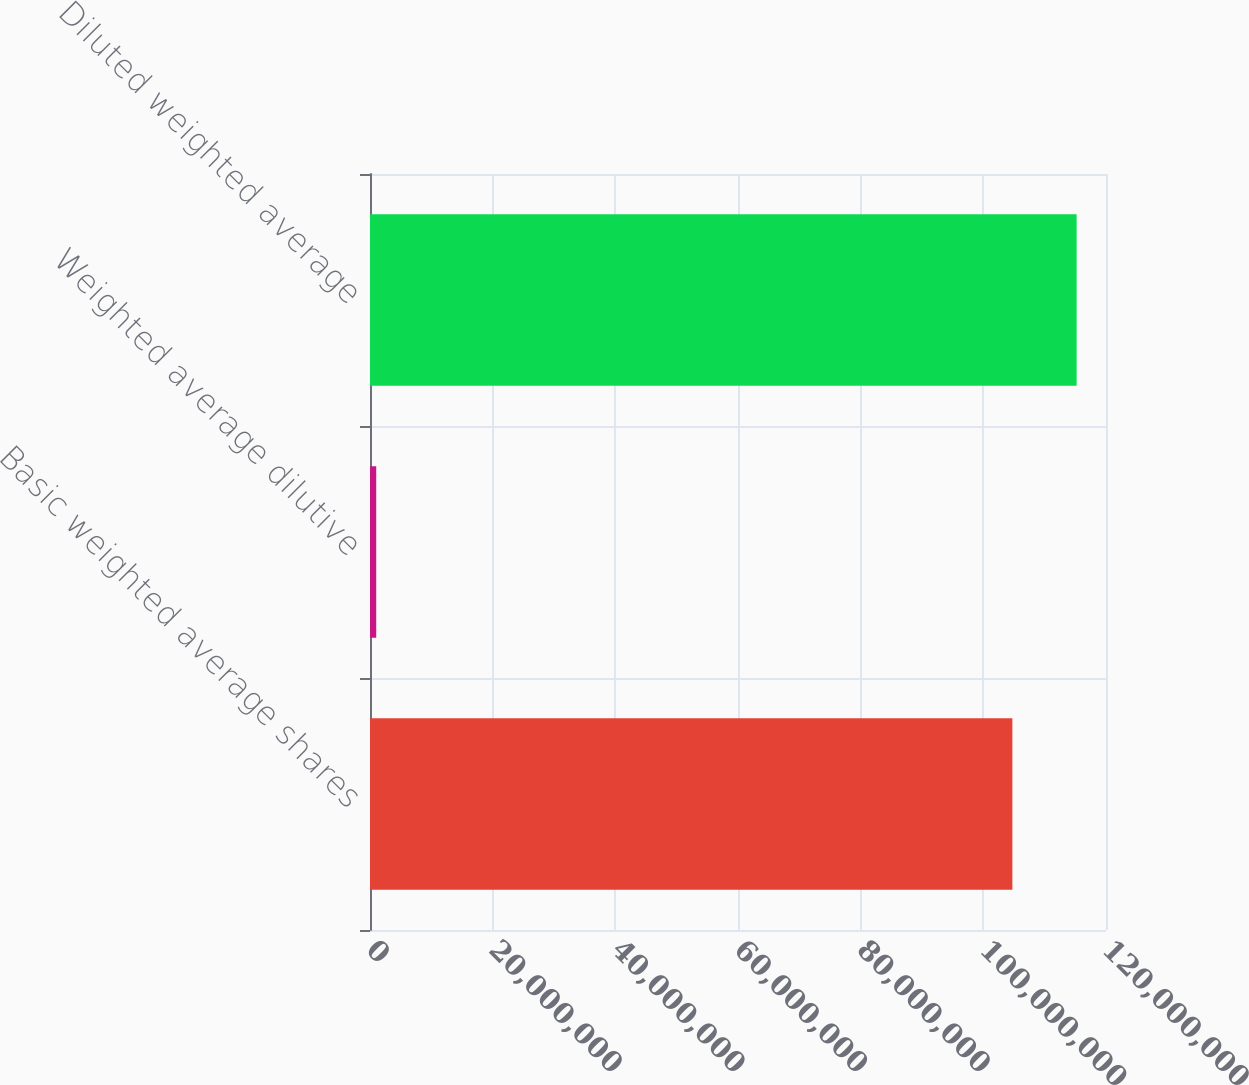Convert chart. <chart><loc_0><loc_0><loc_500><loc_500><bar_chart><fcel>Basic weighted average shares<fcel>Weighted average dilutive<fcel>Diluted weighted average<nl><fcel>1.04735e+08<fcel>1.01595e+06<fcel>1.15209e+08<nl></chart> 